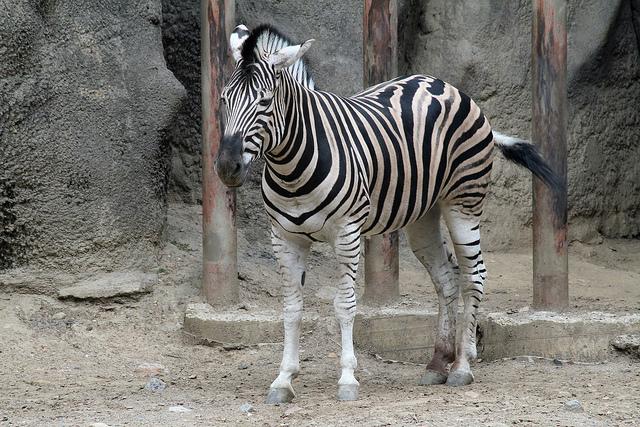What color is the mane?
Be succinct. Black and white. Is this zebra in a zoo?
Quick response, please. Yes. What is the zebra doing?
Short answer required. Standing. 